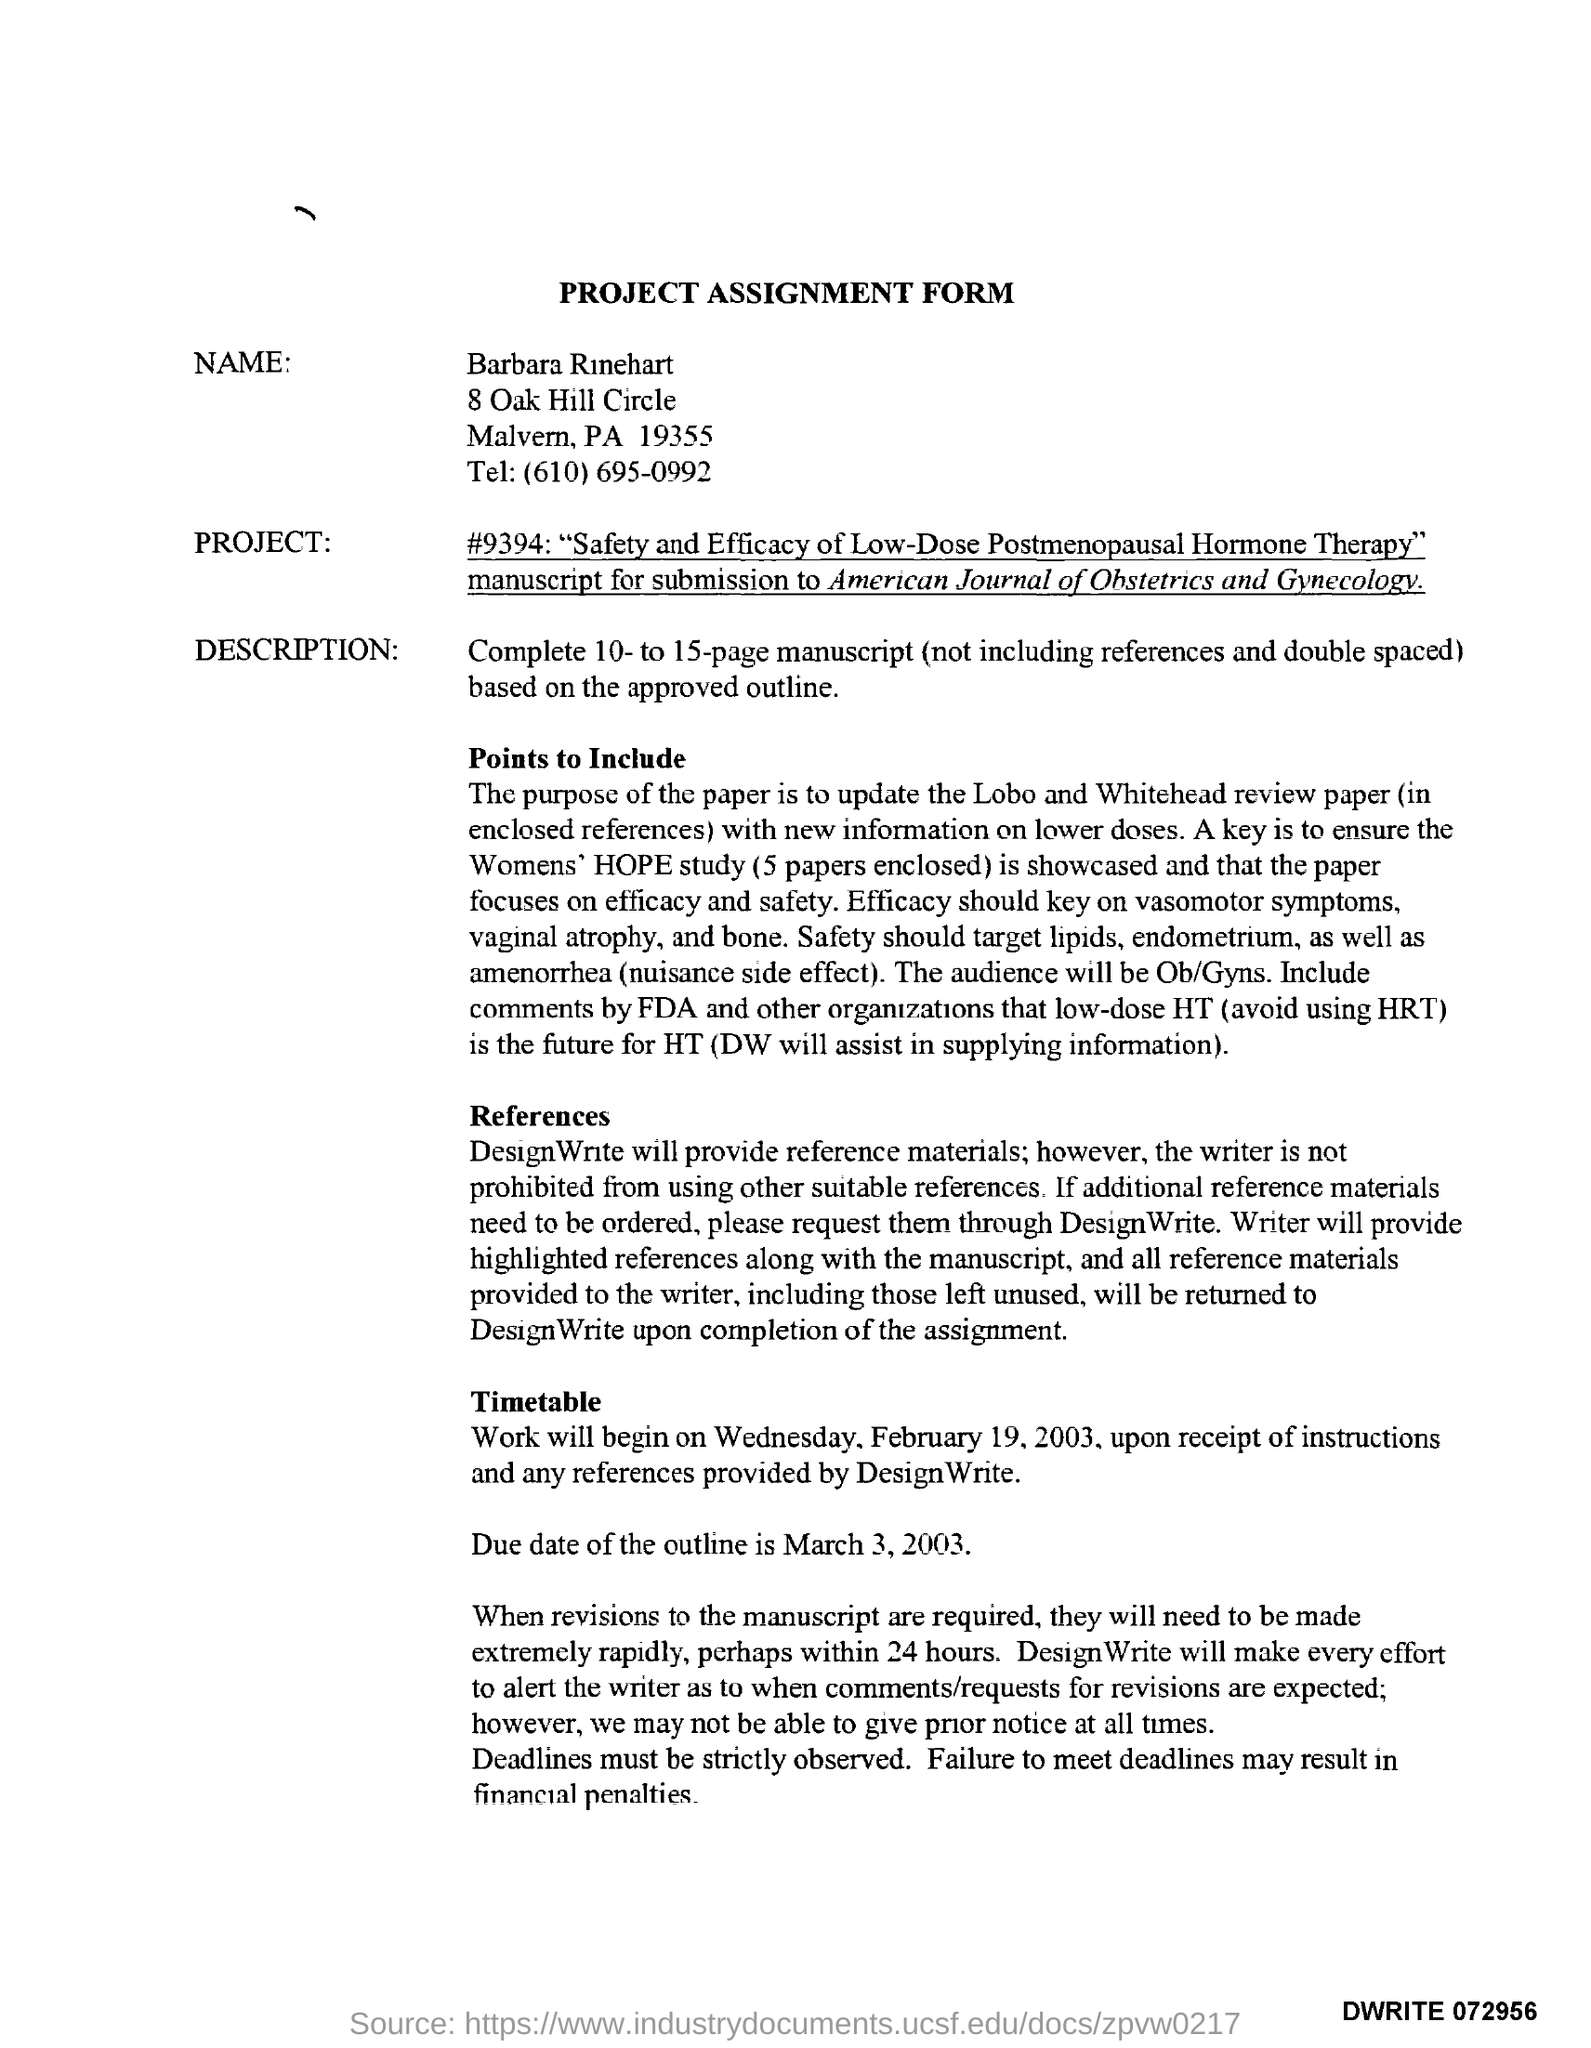What is the name written in the project assignment form ?
Give a very brief answer. Barbara Rinehart. What is the due date of outline mentioned in the assignment form ?
Give a very brief answer. March 3, 2003. 